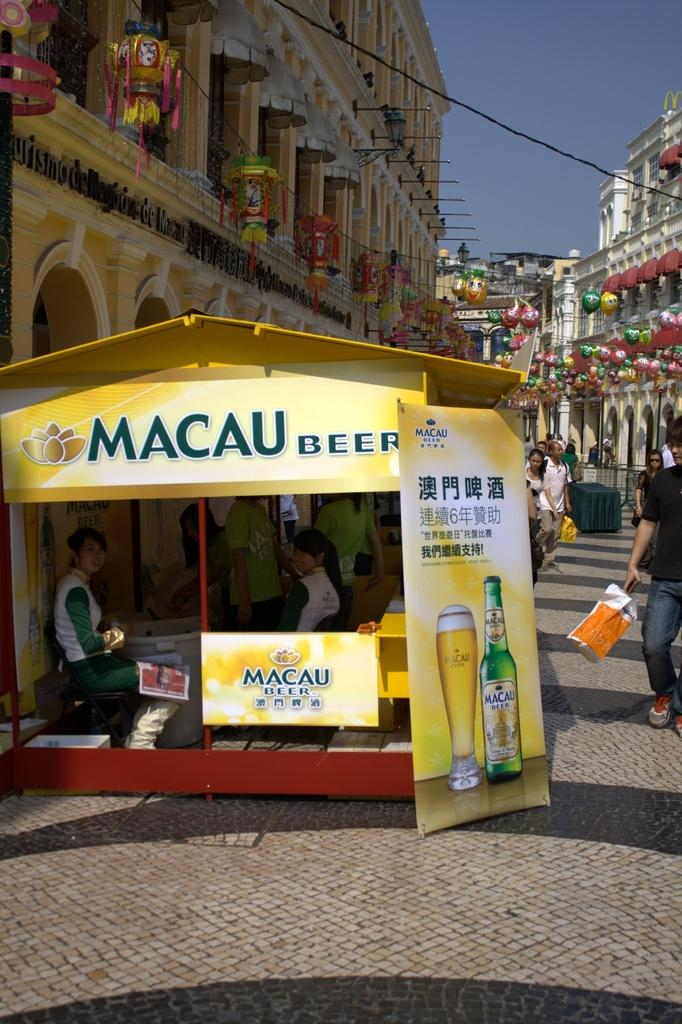<image>
Give a short and clear explanation of the subsequent image. The yellow tent is advertising Macau beer and people sit in it. 